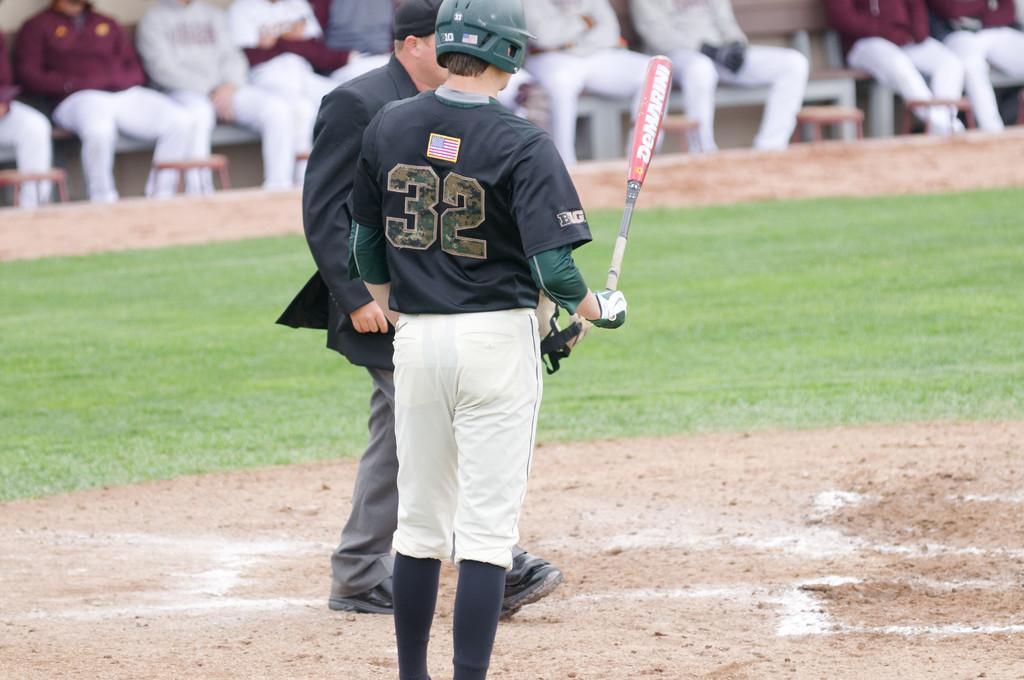Can you describe this image briefly? In this image, we can see a man standing and holding a baseball stick, he is wearing a helmet, there is a man walking, in the background there are some people siting, there is green grass on the ground at some area. 